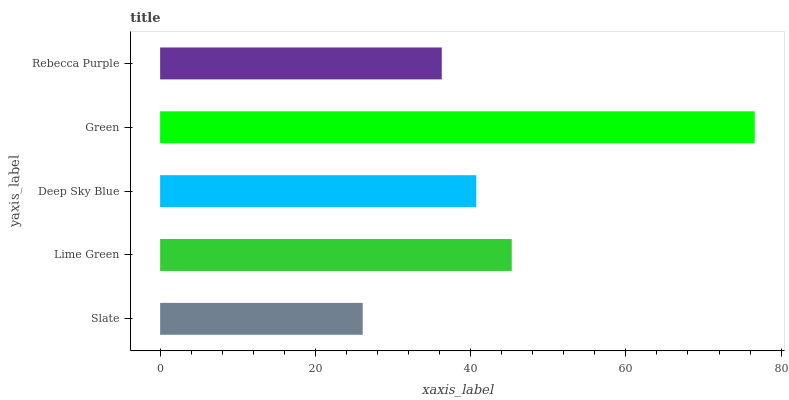Is Slate the minimum?
Answer yes or no. Yes. Is Green the maximum?
Answer yes or no. Yes. Is Lime Green the minimum?
Answer yes or no. No. Is Lime Green the maximum?
Answer yes or no. No. Is Lime Green greater than Slate?
Answer yes or no. Yes. Is Slate less than Lime Green?
Answer yes or no. Yes. Is Slate greater than Lime Green?
Answer yes or no. No. Is Lime Green less than Slate?
Answer yes or no. No. Is Deep Sky Blue the high median?
Answer yes or no. Yes. Is Deep Sky Blue the low median?
Answer yes or no. Yes. Is Green the high median?
Answer yes or no. No. Is Green the low median?
Answer yes or no. No. 